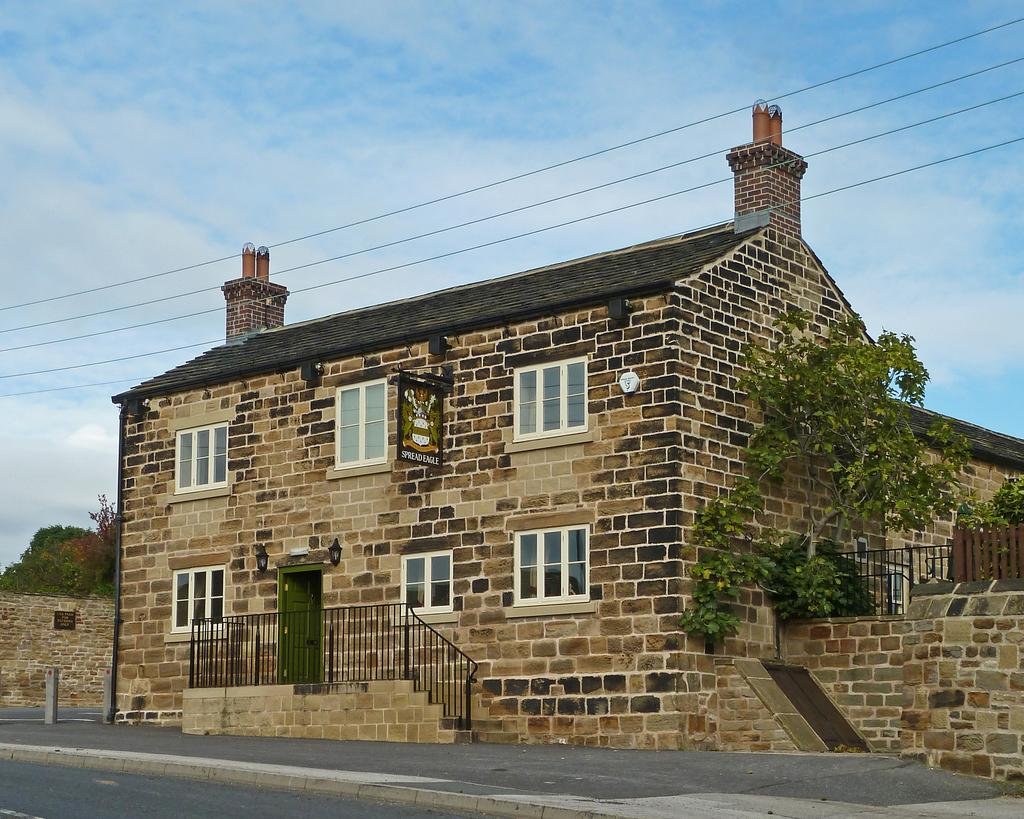What type of pathway can be seen in the image? There is a road in the image. What structures are present in the image? There are buildings in the image. What architectural features can be seen on the buildings? Windows and doors are visible in the image. What type of vegetation is present in the image? Trees are in the image. What man-made structures are present in the image? Electric wires and railings are visible in the image. What type of barrier is present in the image? There is a fence in the image. What can be seen in the sky in the image? Clouds are visible in the sky. Can you tell me how many chickens are walking on the road in the image? There are no chickens present in the image; it features a road, buildings, trees, and other man-made structures. What type of twist can be seen in the image? There is no twist present in the image; it is a scene featuring a road, buildings, trees, and other man-made structures. 